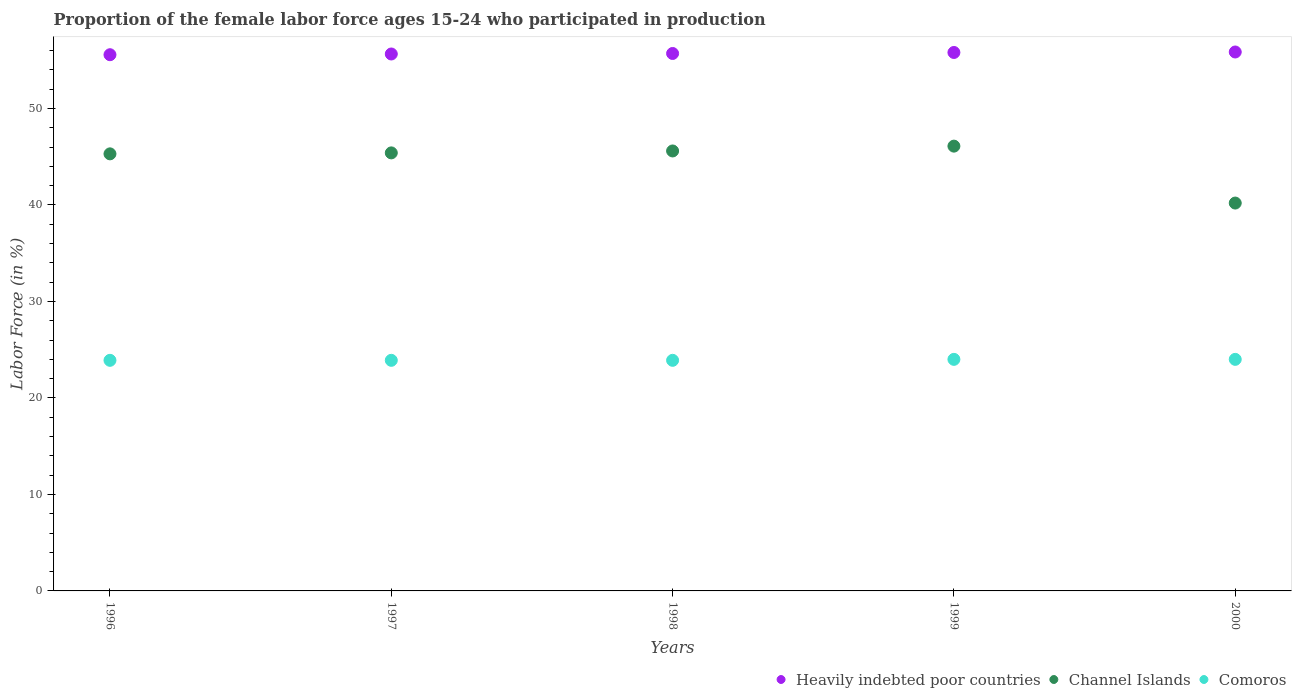Is the number of dotlines equal to the number of legend labels?
Ensure brevity in your answer.  Yes. What is the proportion of the female labor force who participated in production in Comoros in 1999?
Your answer should be very brief. 24. Across all years, what is the minimum proportion of the female labor force who participated in production in Comoros?
Offer a very short reply. 23.9. In which year was the proportion of the female labor force who participated in production in Heavily indebted poor countries maximum?
Your answer should be compact. 2000. In which year was the proportion of the female labor force who participated in production in Channel Islands minimum?
Make the answer very short. 2000. What is the total proportion of the female labor force who participated in production in Heavily indebted poor countries in the graph?
Keep it short and to the point. 278.59. What is the difference between the proportion of the female labor force who participated in production in Channel Islands in 1997 and that in 2000?
Ensure brevity in your answer.  5.2. What is the difference between the proportion of the female labor force who participated in production in Comoros in 1999 and the proportion of the female labor force who participated in production in Channel Islands in 2000?
Offer a very short reply. -16.2. What is the average proportion of the female labor force who participated in production in Heavily indebted poor countries per year?
Your response must be concise. 55.72. In the year 1996, what is the difference between the proportion of the female labor force who participated in production in Channel Islands and proportion of the female labor force who participated in production in Heavily indebted poor countries?
Ensure brevity in your answer.  -10.27. In how many years, is the proportion of the female labor force who participated in production in Heavily indebted poor countries greater than 10 %?
Make the answer very short. 5. What is the ratio of the proportion of the female labor force who participated in production in Heavily indebted poor countries in 1997 to that in 2000?
Offer a very short reply. 1. Is the difference between the proportion of the female labor force who participated in production in Channel Islands in 1996 and 2000 greater than the difference between the proportion of the female labor force who participated in production in Heavily indebted poor countries in 1996 and 2000?
Provide a succinct answer. Yes. What is the difference between the highest and the lowest proportion of the female labor force who participated in production in Comoros?
Provide a succinct answer. 0.1. Does the proportion of the female labor force who participated in production in Channel Islands monotonically increase over the years?
Offer a terse response. No. Is the proportion of the female labor force who participated in production in Heavily indebted poor countries strictly greater than the proportion of the female labor force who participated in production in Comoros over the years?
Your answer should be very brief. Yes. Is the proportion of the female labor force who participated in production in Comoros strictly less than the proportion of the female labor force who participated in production in Heavily indebted poor countries over the years?
Offer a terse response. Yes. How many dotlines are there?
Your answer should be compact. 3. How many years are there in the graph?
Your answer should be very brief. 5. What is the difference between two consecutive major ticks on the Y-axis?
Provide a short and direct response. 10. Are the values on the major ticks of Y-axis written in scientific E-notation?
Make the answer very short. No. Where does the legend appear in the graph?
Make the answer very short. Bottom right. How are the legend labels stacked?
Ensure brevity in your answer.  Horizontal. What is the title of the graph?
Provide a short and direct response. Proportion of the female labor force ages 15-24 who participated in production. What is the label or title of the X-axis?
Provide a short and direct response. Years. What is the label or title of the Y-axis?
Your answer should be compact. Labor Force (in %). What is the Labor Force (in %) of Heavily indebted poor countries in 1996?
Your answer should be compact. 55.57. What is the Labor Force (in %) of Channel Islands in 1996?
Give a very brief answer. 45.3. What is the Labor Force (in %) in Comoros in 1996?
Provide a succinct answer. 23.9. What is the Labor Force (in %) of Heavily indebted poor countries in 1997?
Provide a succinct answer. 55.65. What is the Labor Force (in %) of Channel Islands in 1997?
Your answer should be compact. 45.4. What is the Labor Force (in %) of Comoros in 1997?
Offer a very short reply. 23.9. What is the Labor Force (in %) in Heavily indebted poor countries in 1998?
Ensure brevity in your answer.  55.7. What is the Labor Force (in %) of Channel Islands in 1998?
Your answer should be compact. 45.6. What is the Labor Force (in %) in Comoros in 1998?
Your response must be concise. 23.9. What is the Labor Force (in %) in Heavily indebted poor countries in 1999?
Provide a succinct answer. 55.81. What is the Labor Force (in %) in Channel Islands in 1999?
Your answer should be compact. 46.1. What is the Labor Force (in %) of Comoros in 1999?
Offer a terse response. 24. What is the Labor Force (in %) in Heavily indebted poor countries in 2000?
Ensure brevity in your answer.  55.86. What is the Labor Force (in %) of Channel Islands in 2000?
Your answer should be very brief. 40.2. Across all years, what is the maximum Labor Force (in %) in Heavily indebted poor countries?
Your response must be concise. 55.86. Across all years, what is the maximum Labor Force (in %) in Channel Islands?
Your response must be concise. 46.1. Across all years, what is the minimum Labor Force (in %) in Heavily indebted poor countries?
Offer a terse response. 55.57. Across all years, what is the minimum Labor Force (in %) of Channel Islands?
Make the answer very short. 40.2. Across all years, what is the minimum Labor Force (in %) in Comoros?
Provide a succinct answer. 23.9. What is the total Labor Force (in %) of Heavily indebted poor countries in the graph?
Give a very brief answer. 278.59. What is the total Labor Force (in %) in Channel Islands in the graph?
Provide a succinct answer. 222.6. What is the total Labor Force (in %) in Comoros in the graph?
Provide a short and direct response. 119.7. What is the difference between the Labor Force (in %) of Heavily indebted poor countries in 1996 and that in 1997?
Offer a terse response. -0.08. What is the difference between the Labor Force (in %) in Channel Islands in 1996 and that in 1997?
Provide a short and direct response. -0.1. What is the difference between the Labor Force (in %) of Comoros in 1996 and that in 1997?
Make the answer very short. 0. What is the difference between the Labor Force (in %) in Heavily indebted poor countries in 1996 and that in 1998?
Your answer should be compact. -0.13. What is the difference between the Labor Force (in %) in Comoros in 1996 and that in 1998?
Keep it short and to the point. 0. What is the difference between the Labor Force (in %) of Heavily indebted poor countries in 1996 and that in 1999?
Your answer should be compact. -0.23. What is the difference between the Labor Force (in %) of Channel Islands in 1996 and that in 1999?
Provide a succinct answer. -0.8. What is the difference between the Labor Force (in %) of Comoros in 1996 and that in 1999?
Make the answer very short. -0.1. What is the difference between the Labor Force (in %) of Heavily indebted poor countries in 1996 and that in 2000?
Offer a terse response. -0.28. What is the difference between the Labor Force (in %) in Channel Islands in 1996 and that in 2000?
Provide a short and direct response. 5.1. What is the difference between the Labor Force (in %) in Heavily indebted poor countries in 1997 and that in 1998?
Your answer should be very brief. -0.05. What is the difference between the Labor Force (in %) of Channel Islands in 1997 and that in 1998?
Make the answer very short. -0.2. What is the difference between the Labor Force (in %) of Comoros in 1997 and that in 1998?
Make the answer very short. 0. What is the difference between the Labor Force (in %) in Heavily indebted poor countries in 1997 and that in 1999?
Offer a terse response. -0.16. What is the difference between the Labor Force (in %) of Heavily indebted poor countries in 1997 and that in 2000?
Offer a very short reply. -0.21. What is the difference between the Labor Force (in %) of Heavily indebted poor countries in 1998 and that in 1999?
Offer a very short reply. -0.1. What is the difference between the Labor Force (in %) of Comoros in 1998 and that in 1999?
Provide a succinct answer. -0.1. What is the difference between the Labor Force (in %) in Heavily indebted poor countries in 1998 and that in 2000?
Make the answer very short. -0.15. What is the difference between the Labor Force (in %) in Comoros in 1998 and that in 2000?
Your response must be concise. -0.1. What is the difference between the Labor Force (in %) of Heavily indebted poor countries in 1999 and that in 2000?
Your answer should be compact. -0.05. What is the difference between the Labor Force (in %) in Heavily indebted poor countries in 1996 and the Labor Force (in %) in Channel Islands in 1997?
Your response must be concise. 10.17. What is the difference between the Labor Force (in %) of Heavily indebted poor countries in 1996 and the Labor Force (in %) of Comoros in 1997?
Offer a terse response. 31.67. What is the difference between the Labor Force (in %) of Channel Islands in 1996 and the Labor Force (in %) of Comoros in 1997?
Your answer should be compact. 21.4. What is the difference between the Labor Force (in %) of Heavily indebted poor countries in 1996 and the Labor Force (in %) of Channel Islands in 1998?
Give a very brief answer. 9.97. What is the difference between the Labor Force (in %) of Heavily indebted poor countries in 1996 and the Labor Force (in %) of Comoros in 1998?
Your answer should be very brief. 31.67. What is the difference between the Labor Force (in %) in Channel Islands in 1996 and the Labor Force (in %) in Comoros in 1998?
Offer a very short reply. 21.4. What is the difference between the Labor Force (in %) of Heavily indebted poor countries in 1996 and the Labor Force (in %) of Channel Islands in 1999?
Offer a very short reply. 9.47. What is the difference between the Labor Force (in %) of Heavily indebted poor countries in 1996 and the Labor Force (in %) of Comoros in 1999?
Provide a short and direct response. 31.57. What is the difference between the Labor Force (in %) of Channel Islands in 1996 and the Labor Force (in %) of Comoros in 1999?
Offer a very short reply. 21.3. What is the difference between the Labor Force (in %) in Heavily indebted poor countries in 1996 and the Labor Force (in %) in Channel Islands in 2000?
Provide a short and direct response. 15.37. What is the difference between the Labor Force (in %) of Heavily indebted poor countries in 1996 and the Labor Force (in %) of Comoros in 2000?
Offer a very short reply. 31.57. What is the difference between the Labor Force (in %) of Channel Islands in 1996 and the Labor Force (in %) of Comoros in 2000?
Your answer should be compact. 21.3. What is the difference between the Labor Force (in %) of Heavily indebted poor countries in 1997 and the Labor Force (in %) of Channel Islands in 1998?
Your answer should be compact. 10.05. What is the difference between the Labor Force (in %) of Heavily indebted poor countries in 1997 and the Labor Force (in %) of Comoros in 1998?
Your response must be concise. 31.75. What is the difference between the Labor Force (in %) in Heavily indebted poor countries in 1997 and the Labor Force (in %) in Channel Islands in 1999?
Your answer should be very brief. 9.55. What is the difference between the Labor Force (in %) in Heavily indebted poor countries in 1997 and the Labor Force (in %) in Comoros in 1999?
Your response must be concise. 31.65. What is the difference between the Labor Force (in %) in Channel Islands in 1997 and the Labor Force (in %) in Comoros in 1999?
Offer a very short reply. 21.4. What is the difference between the Labor Force (in %) in Heavily indebted poor countries in 1997 and the Labor Force (in %) in Channel Islands in 2000?
Provide a succinct answer. 15.45. What is the difference between the Labor Force (in %) of Heavily indebted poor countries in 1997 and the Labor Force (in %) of Comoros in 2000?
Offer a very short reply. 31.65. What is the difference between the Labor Force (in %) in Channel Islands in 1997 and the Labor Force (in %) in Comoros in 2000?
Provide a succinct answer. 21.4. What is the difference between the Labor Force (in %) in Heavily indebted poor countries in 1998 and the Labor Force (in %) in Channel Islands in 1999?
Your answer should be very brief. 9.6. What is the difference between the Labor Force (in %) in Heavily indebted poor countries in 1998 and the Labor Force (in %) in Comoros in 1999?
Make the answer very short. 31.7. What is the difference between the Labor Force (in %) in Channel Islands in 1998 and the Labor Force (in %) in Comoros in 1999?
Your response must be concise. 21.6. What is the difference between the Labor Force (in %) of Heavily indebted poor countries in 1998 and the Labor Force (in %) of Channel Islands in 2000?
Offer a terse response. 15.5. What is the difference between the Labor Force (in %) of Heavily indebted poor countries in 1998 and the Labor Force (in %) of Comoros in 2000?
Offer a very short reply. 31.7. What is the difference between the Labor Force (in %) in Channel Islands in 1998 and the Labor Force (in %) in Comoros in 2000?
Give a very brief answer. 21.6. What is the difference between the Labor Force (in %) in Heavily indebted poor countries in 1999 and the Labor Force (in %) in Channel Islands in 2000?
Offer a terse response. 15.61. What is the difference between the Labor Force (in %) in Heavily indebted poor countries in 1999 and the Labor Force (in %) in Comoros in 2000?
Your answer should be very brief. 31.81. What is the difference between the Labor Force (in %) of Channel Islands in 1999 and the Labor Force (in %) of Comoros in 2000?
Your answer should be compact. 22.1. What is the average Labor Force (in %) in Heavily indebted poor countries per year?
Provide a short and direct response. 55.72. What is the average Labor Force (in %) of Channel Islands per year?
Offer a very short reply. 44.52. What is the average Labor Force (in %) of Comoros per year?
Offer a terse response. 23.94. In the year 1996, what is the difference between the Labor Force (in %) in Heavily indebted poor countries and Labor Force (in %) in Channel Islands?
Make the answer very short. 10.27. In the year 1996, what is the difference between the Labor Force (in %) of Heavily indebted poor countries and Labor Force (in %) of Comoros?
Keep it short and to the point. 31.67. In the year 1996, what is the difference between the Labor Force (in %) of Channel Islands and Labor Force (in %) of Comoros?
Offer a very short reply. 21.4. In the year 1997, what is the difference between the Labor Force (in %) of Heavily indebted poor countries and Labor Force (in %) of Channel Islands?
Give a very brief answer. 10.25. In the year 1997, what is the difference between the Labor Force (in %) in Heavily indebted poor countries and Labor Force (in %) in Comoros?
Provide a succinct answer. 31.75. In the year 1997, what is the difference between the Labor Force (in %) in Channel Islands and Labor Force (in %) in Comoros?
Provide a short and direct response. 21.5. In the year 1998, what is the difference between the Labor Force (in %) in Heavily indebted poor countries and Labor Force (in %) in Channel Islands?
Make the answer very short. 10.1. In the year 1998, what is the difference between the Labor Force (in %) of Heavily indebted poor countries and Labor Force (in %) of Comoros?
Offer a very short reply. 31.8. In the year 1998, what is the difference between the Labor Force (in %) in Channel Islands and Labor Force (in %) in Comoros?
Keep it short and to the point. 21.7. In the year 1999, what is the difference between the Labor Force (in %) of Heavily indebted poor countries and Labor Force (in %) of Channel Islands?
Your answer should be very brief. 9.71. In the year 1999, what is the difference between the Labor Force (in %) in Heavily indebted poor countries and Labor Force (in %) in Comoros?
Provide a succinct answer. 31.81. In the year 1999, what is the difference between the Labor Force (in %) of Channel Islands and Labor Force (in %) of Comoros?
Your answer should be very brief. 22.1. In the year 2000, what is the difference between the Labor Force (in %) of Heavily indebted poor countries and Labor Force (in %) of Channel Islands?
Your response must be concise. 15.66. In the year 2000, what is the difference between the Labor Force (in %) in Heavily indebted poor countries and Labor Force (in %) in Comoros?
Your response must be concise. 31.86. What is the ratio of the Labor Force (in %) of Comoros in 1996 to that in 1998?
Make the answer very short. 1. What is the ratio of the Labor Force (in %) in Channel Islands in 1996 to that in 1999?
Make the answer very short. 0.98. What is the ratio of the Labor Force (in %) of Channel Islands in 1996 to that in 2000?
Offer a terse response. 1.13. What is the ratio of the Labor Force (in %) in Comoros in 1996 to that in 2000?
Keep it short and to the point. 1. What is the ratio of the Labor Force (in %) of Channel Islands in 1997 to that in 1998?
Your response must be concise. 1. What is the ratio of the Labor Force (in %) in Comoros in 1997 to that in 1998?
Keep it short and to the point. 1. What is the ratio of the Labor Force (in %) of Heavily indebted poor countries in 1997 to that in 1999?
Offer a terse response. 1. What is the ratio of the Labor Force (in %) in Comoros in 1997 to that in 1999?
Give a very brief answer. 1. What is the ratio of the Labor Force (in %) in Heavily indebted poor countries in 1997 to that in 2000?
Keep it short and to the point. 1. What is the ratio of the Labor Force (in %) in Channel Islands in 1997 to that in 2000?
Your response must be concise. 1.13. What is the ratio of the Labor Force (in %) of Heavily indebted poor countries in 1998 to that in 1999?
Give a very brief answer. 1. What is the ratio of the Labor Force (in %) of Comoros in 1998 to that in 1999?
Ensure brevity in your answer.  1. What is the ratio of the Labor Force (in %) in Channel Islands in 1998 to that in 2000?
Give a very brief answer. 1.13. What is the ratio of the Labor Force (in %) in Channel Islands in 1999 to that in 2000?
Your answer should be very brief. 1.15. What is the ratio of the Labor Force (in %) in Comoros in 1999 to that in 2000?
Your answer should be very brief. 1. What is the difference between the highest and the second highest Labor Force (in %) in Heavily indebted poor countries?
Provide a succinct answer. 0.05. What is the difference between the highest and the second highest Labor Force (in %) of Channel Islands?
Offer a very short reply. 0.5. What is the difference between the highest and the lowest Labor Force (in %) in Heavily indebted poor countries?
Your answer should be compact. 0.28. What is the difference between the highest and the lowest Labor Force (in %) of Comoros?
Ensure brevity in your answer.  0.1. 